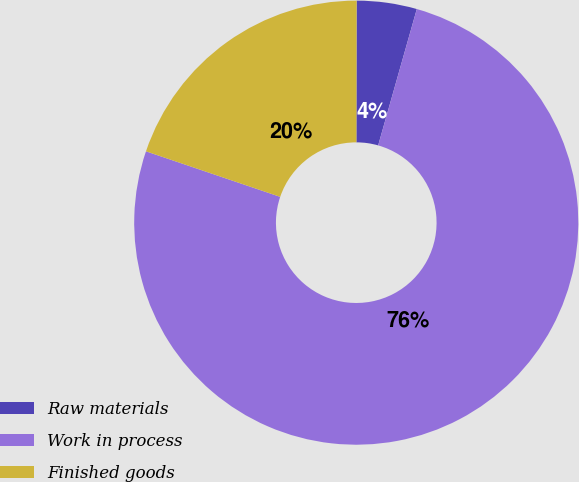Convert chart. <chart><loc_0><loc_0><loc_500><loc_500><pie_chart><fcel>Raw materials<fcel>Work in process<fcel>Finished goods<nl><fcel>4.37%<fcel>75.81%<fcel>19.82%<nl></chart> 